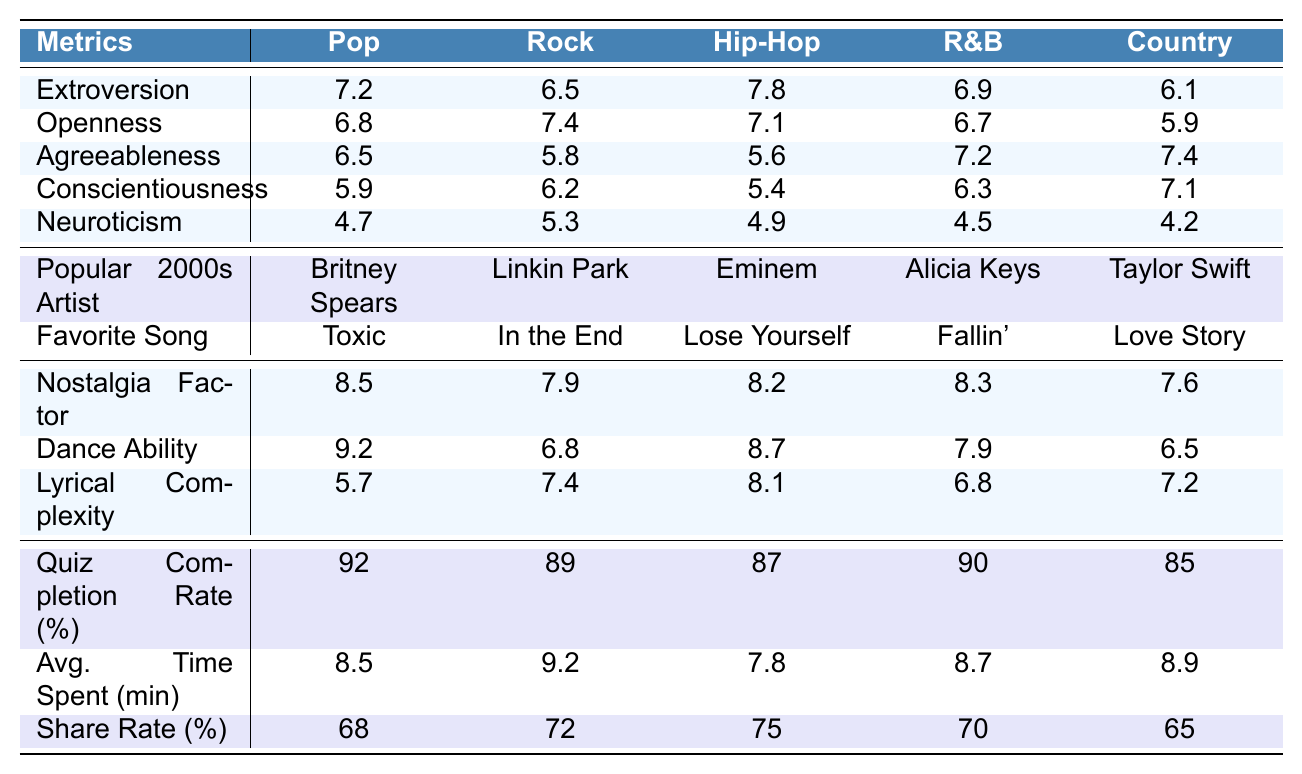What is the most popular song associated with the Hip-Hop genre? The table lists the favorite songs for each genre. For Hip-Hop, the popular song is "Lose Yourself."
Answer: Lose Yourself Which genre has the highest score in Agreeableness? Looking at the Agreeableness scores for each genre, Country has the highest score of 7.4 compared to others.
Answer: Country What is the average Neuroticism score across all genres? To find the average, sum the Neuroticism scores: (4.7 + 5.3 + 4.9 + 4.5 + 4.2) = 23.6. Then, divide by 5 (number of genres): 23.6 / 5 = 4.72.
Answer: 4.72 Is the quiz completion rate for R&B higher than that for Pop? The quiz completion rate for R&B is 90%, while for Pop it is 92%. Since 90% is less than 92%, the statement is false.
Answer: No Which genre has the highest Nostalgia Factor and what is the value? By checking the Nostalgia Factor values, Pop is the highest at 8.5.
Answer: 8.5 What is the difference in Dance Ability scores between Pop and Country? Pop has a Dance Ability score of 9.2 and Country has 6.5. The difference is 9.2 - 6.5 = 2.7.
Answer: 2.7 For which genre is the average time spent on the quiz the highest? The average time spent on the quiz for each genre shows Rock at 9.2 minutes, which is the highest compared to the others.
Answer: Rock Does Hip-Hop have a lower Lyrical Complexity than R&B? Hip-Hop has a Lyrical Complexity of 8.1, while R&B has 6.8. Therefore, Hip-Hop does not have a lower score than R&B.
Answer: No What genre has the lowest score in Conscientiousness and what is that score? The Conscientiousness scores reveal that Hip-Hop has the lowest score of 5.4 when compared to others.
Answer: Hip-Hop, 5.4 If we add the Extroversion scores from Pop and R&B, what is the result? The Extroversion score for Pop is 7.2 and for R&B it is 6.9. Adding these together: 7.2 + 6.9 = 14.1.
Answer: 14.1 